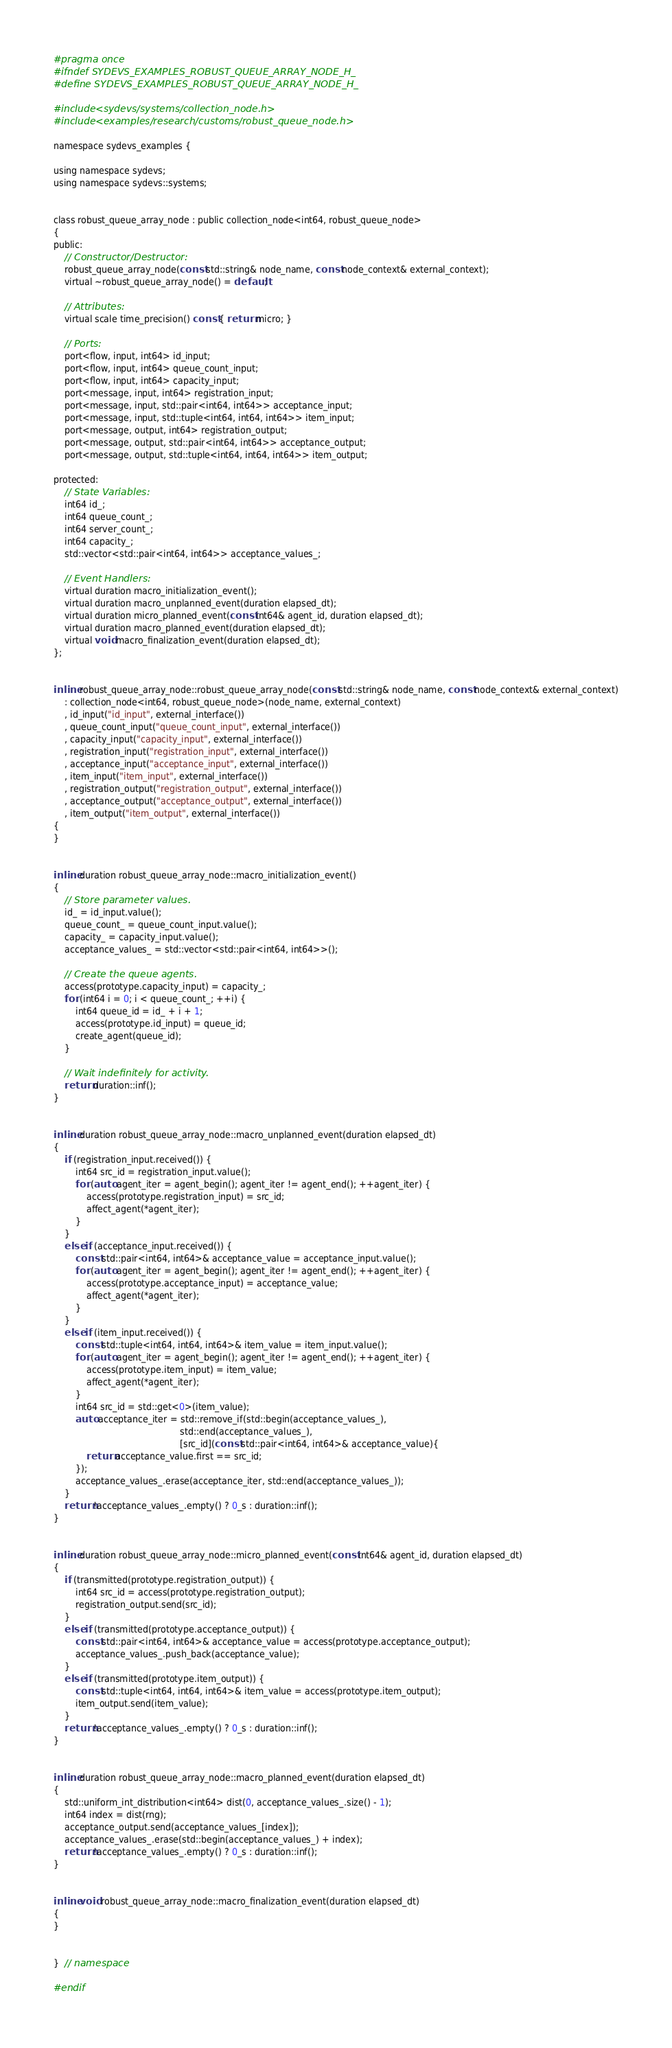<code> <loc_0><loc_0><loc_500><loc_500><_C_>#pragma once
#ifndef SYDEVS_EXAMPLES_ROBUST_QUEUE_ARRAY_NODE_H_
#define SYDEVS_EXAMPLES_ROBUST_QUEUE_ARRAY_NODE_H_

#include <sydevs/systems/collection_node.h>
#include <examples/research/customs/robust_queue_node.h>

namespace sydevs_examples {

using namespace sydevs;
using namespace sydevs::systems;


class robust_queue_array_node : public collection_node<int64, robust_queue_node>
{
public:
    // Constructor/Destructor:
    robust_queue_array_node(const std::string& node_name, const node_context& external_context);
    virtual ~robust_queue_array_node() = default;

    // Attributes:
    virtual scale time_precision() const { return micro; }

    // Ports:
    port<flow, input, int64> id_input;
    port<flow, input, int64> queue_count_input;
    port<flow, input, int64> capacity_input;
    port<message, input, int64> registration_input;
    port<message, input, std::pair<int64, int64>> acceptance_input;
    port<message, input, std::tuple<int64, int64, int64>> item_input;
    port<message, output, int64> registration_output;
    port<message, output, std::pair<int64, int64>> acceptance_output;
    port<message, output, std::tuple<int64, int64, int64>> item_output;

protected:
    // State Variables:
    int64 id_;
    int64 queue_count_;
    int64 server_count_;
    int64 capacity_;
    std::vector<std::pair<int64, int64>> acceptance_values_;

    // Event Handlers:
    virtual duration macro_initialization_event();
    virtual duration macro_unplanned_event(duration elapsed_dt);
    virtual duration micro_planned_event(const int64& agent_id, duration elapsed_dt);
    virtual duration macro_planned_event(duration elapsed_dt);
    virtual void macro_finalization_event(duration elapsed_dt);
};


inline robust_queue_array_node::robust_queue_array_node(const std::string& node_name, const node_context& external_context)
    : collection_node<int64, robust_queue_node>(node_name, external_context)
    , id_input("id_input", external_interface())
    , queue_count_input("queue_count_input", external_interface())
    , capacity_input("capacity_input", external_interface())
    , registration_input("registration_input", external_interface())
    , acceptance_input("acceptance_input", external_interface())
    , item_input("item_input", external_interface())
    , registration_output("registration_output", external_interface())
    , acceptance_output("acceptance_output", external_interface())
    , item_output("item_output", external_interface())
{
}


inline duration robust_queue_array_node::macro_initialization_event()
{
    // Store parameter values.
    id_ = id_input.value();
    queue_count_ = queue_count_input.value();
    capacity_ = capacity_input.value();
    acceptance_values_ = std::vector<std::pair<int64, int64>>();

    // Create the queue agents.
    access(prototype.capacity_input) = capacity_;
    for (int64 i = 0; i < queue_count_; ++i) {
        int64 queue_id = id_ + i + 1;
        access(prototype.id_input) = queue_id;
        create_agent(queue_id);
    }

    // Wait indefinitely for activity.
    return duration::inf();
}


inline duration robust_queue_array_node::macro_unplanned_event(duration elapsed_dt)
{
    if (registration_input.received()) {
        int64 src_id = registration_input.value();
        for (auto agent_iter = agent_begin(); agent_iter != agent_end(); ++agent_iter) {
            access(prototype.registration_input) = src_id;
            affect_agent(*agent_iter);
        }
    }
    else if (acceptance_input.received()) {
        const std::pair<int64, int64>& acceptance_value = acceptance_input.value();
        for (auto agent_iter = agent_begin(); agent_iter != agent_end(); ++agent_iter) {
            access(prototype.acceptance_input) = acceptance_value;
            affect_agent(*agent_iter);
        }
    }
    else if (item_input.received()) {
        const std::tuple<int64, int64, int64>& item_value = item_input.value();
        for (auto agent_iter = agent_begin(); agent_iter != agent_end(); ++agent_iter) {
            access(prototype.item_input) = item_value;
            affect_agent(*agent_iter);
        }
        int64 src_id = std::get<0>(item_value);
        auto acceptance_iter = std::remove_if(std::begin(acceptance_values_), 
                                              std::end(acceptance_values_), 
                                              [src_id](const std::pair<int64, int64>& acceptance_value){
            return acceptance_value.first == src_id;
        });
        acceptance_values_.erase(acceptance_iter, std::end(acceptance_values_));
    }
    return !acceptance_values_.empty() ? 0_s : duration::inf();
}


inline duration robust_queue_array_node::micro_planned_event(const int64& agent_id, duration elapsed_dt)
{
    if (transmitted(prototype.registration_output)) {
        int64 src_id = access(prototype.registration_output);
        registration_output.send(src_id);
    }
    else if (transmitted(prototype.acceptance_output)) {
        const std::pair<int64, int64>& acceptance_value = access(prototype.acceptance_output);
        acceptance_values_.push_back(acceptance_value);
    }
    else if (transmitted(prototype.item_output)) {
        const std::tuple<int64, int64, int64>& item_value = access(prototype.item_output);
        item_output.send(item_value);
    }
    return !acceptance_values_.empty() ? 0_s : duration::inf();
}


inline duration robust_queue_array_node::macro_planned_event(duration elapsed_dt)
{
    std::uniform_int_distribution<int64> dist(0, acceptance_values_.size() - 1);
    int64 index = dist(rng);
    acceptance_output.send(acceptance_values_[index]);
    acceptance_values_.erase(std::begin(acceptance_values_) + index);
    return !acceptance_values_.empty() ? 0_s : duration::inf();
}


inline void robust_queue_array_node::macro_finalization_event(duration elapsed_dt)
{
}


}  // namespace

#endif
</code> 